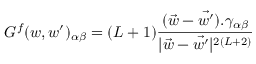<formula> <loc_0><loc_0><loc_500><loc_500>G ^ { f } ( w , w ^ { \prime } ) _ { \alpha \beta } = ( L + 1 ) \frac { { ( \vec { w } - \vec { w ^ { \prime } } ) } . \gamma _ { \alpha \beta } } { | \vec { w } - \vec { w ^ { \prime } } | ^ { 2 ( L + 2 ) } }</formula> 